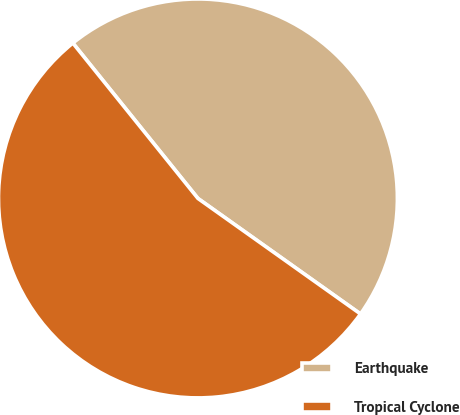Convert chart to OTSL. <chart><loc_0><loc_0><loc_500><loc_500><pie_chart><fcel>Earthquake<fcel>Tropical Cyclone<nl><fcel>45.62%<fcel>54.38%<nl></chart> 